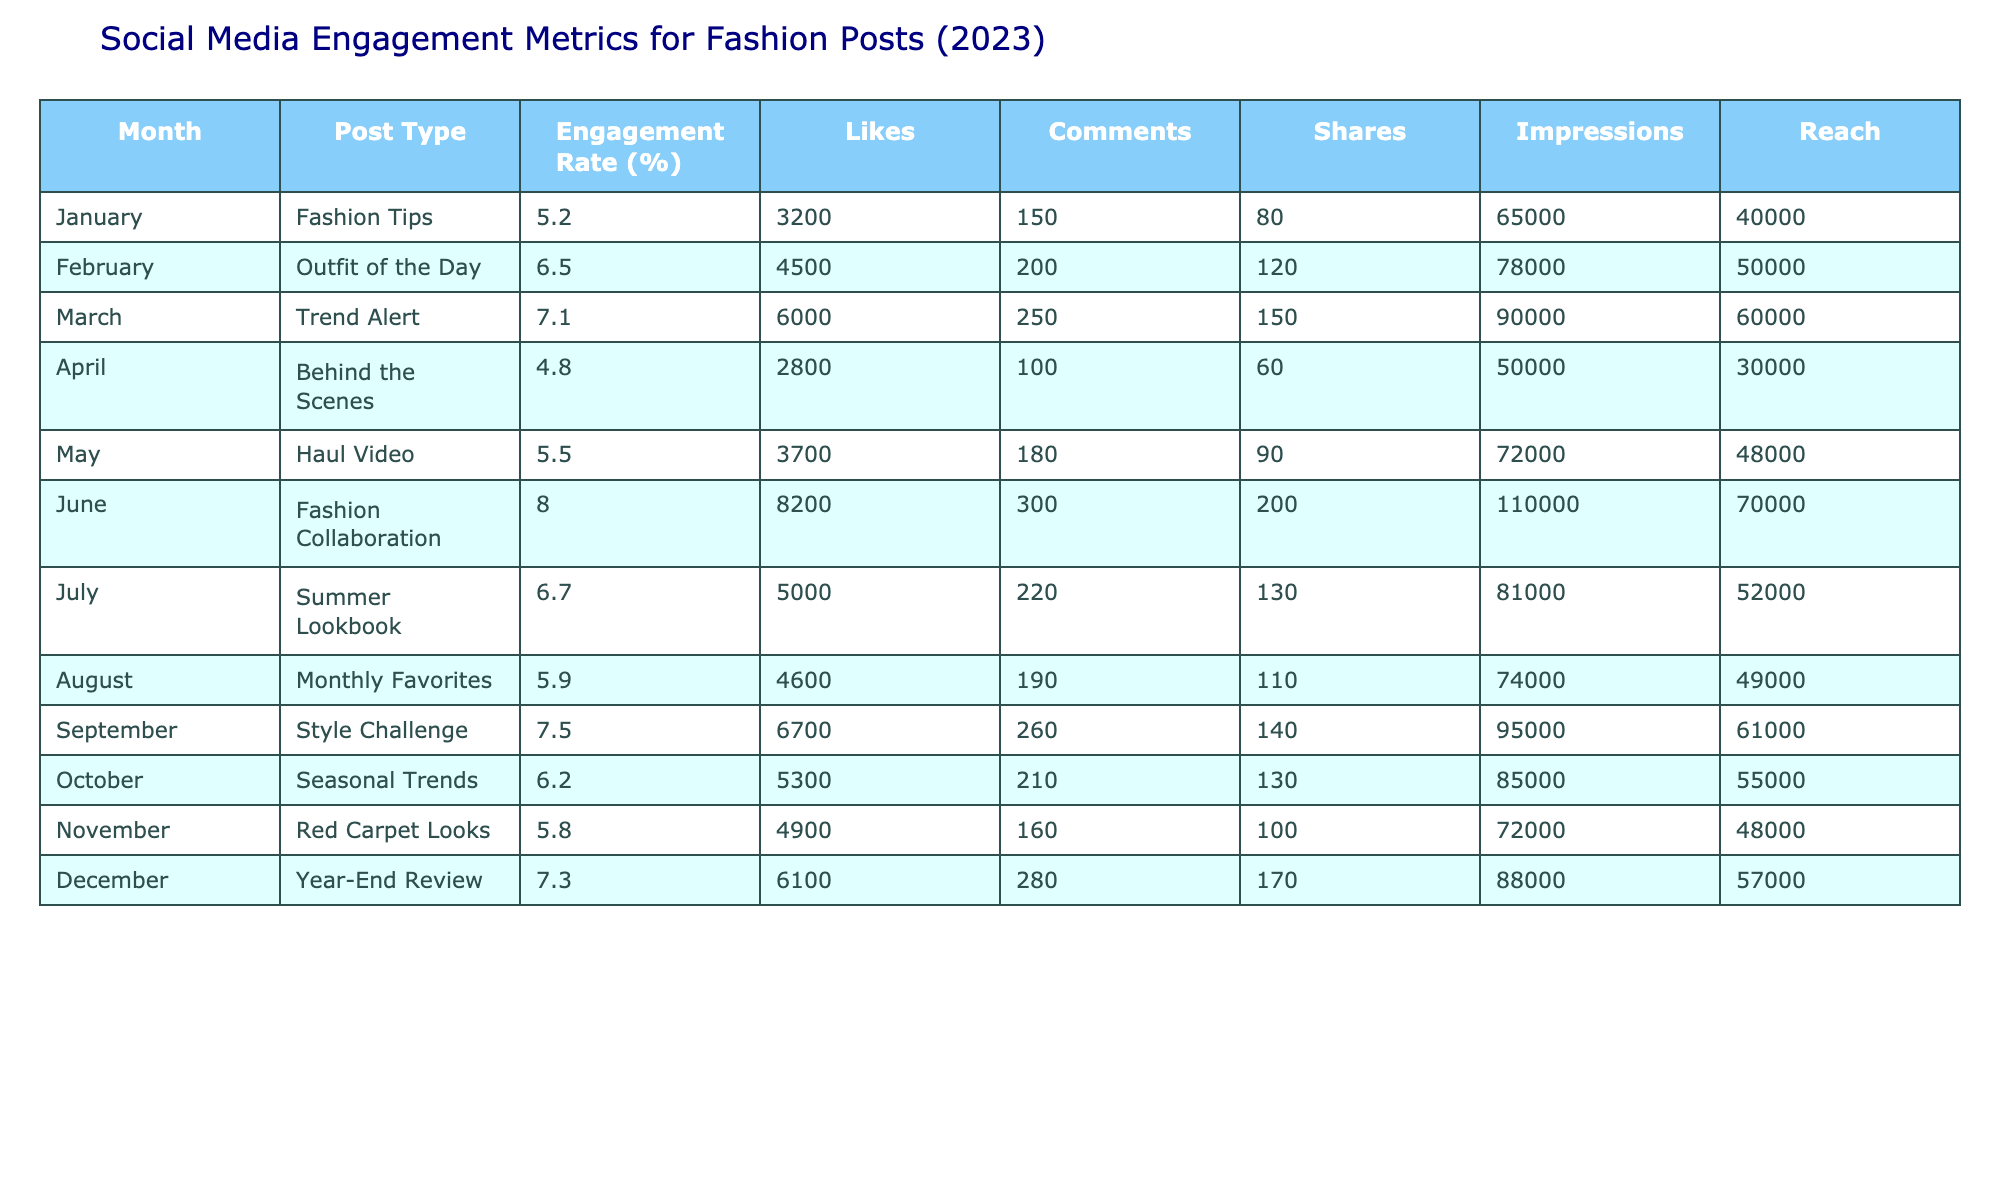What was the engagement rate for the Fashion Tips post in January? The table shows that the engagement rate for the Fashion Tips post in January is 5.2%.
Answer: 5.2% Which month had the highest number of Likes? By examining the Likes column, June had the highest number of Likes at 8200.
Answer: 8200 What is the average Engagement Rate for the posts in the first half of the year (January to June)? The engagement rates for the first half are: 5.2, 6.5, 7.1, 4.8, 5.5, 8.0. The total sum is 37.1, and dividing by 6 gives an average of 6.18%.
Answer: 6.18% Did the number of Shares increase from February to March? The Shares in February are 120, and in March they are 150. Since 150 is greater than 120, the number of Shares increased.
Answer: Yes How many more Likes did the Year-End Review post receive compared to the Behind the Scenes post? The Year-End Review received 6100 Likes, while Behind the Scenes received 2800 Likes. The difference is 6100 - 2800 = 3300 Likes.
Answer: 3300 Likes Which post in August had the greatest Reach, and how many impressions did it achieve? The table indicates that the Monthly Favorites post in August had a Reach of 49000 with 74000 Impressions, as it is the only entry for that month.
Answer: Monthly Favorites with 74000 Impressions What was the total number of Comments across all posts for the year? By summing the Comments column for each post: 150 + 200 + 250 + 100 + 180 + 300 + 220 + 190 + 260 + 210 + 160 + 280 = 2360 Comments for the year.
Answer: 2360 Comments Was the Engagement Rate for July higher than the Engagement Rate for April? The Engagement Rate for July is 6.7%, while for April it is 4.8%. Since 6.7% is greater than 4.8%, July had a higher Engagement Rate.
Answer: Yes Which post type in June had the most interaction measured by the sum of Likes, Comments, and Shares? In June, the Fashion Collaboration post received 8200 Likes, 300 Comments, and 200 Shares. Adding these gives 8200 + 300 + 200 = 8700, which is the highest total for June.
Answer: 8700 interactions 